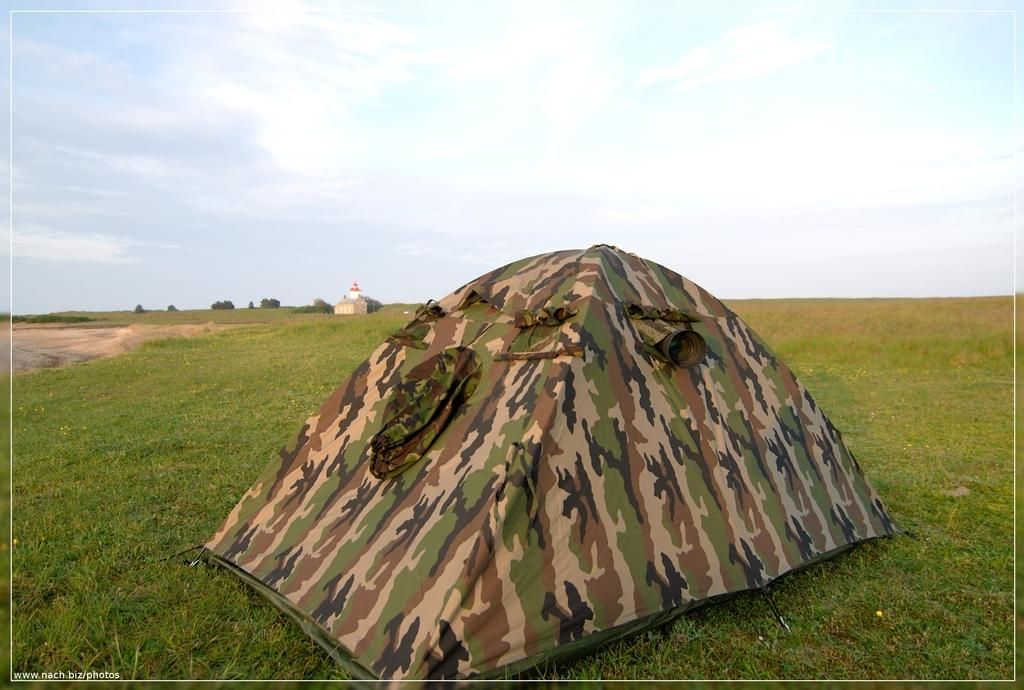What type of shelter is visible in the image? There is a tent in the image. What is the ground covered with in the image? There is green grass on the ground in the image. What can be seen in the sky in the image? There are clouds in the sky in the image. Where is the shelf located in the image? There is no shelf present in the image. What type of wine is being served in the image? There is no wine or serving of wine depicted in the image. 